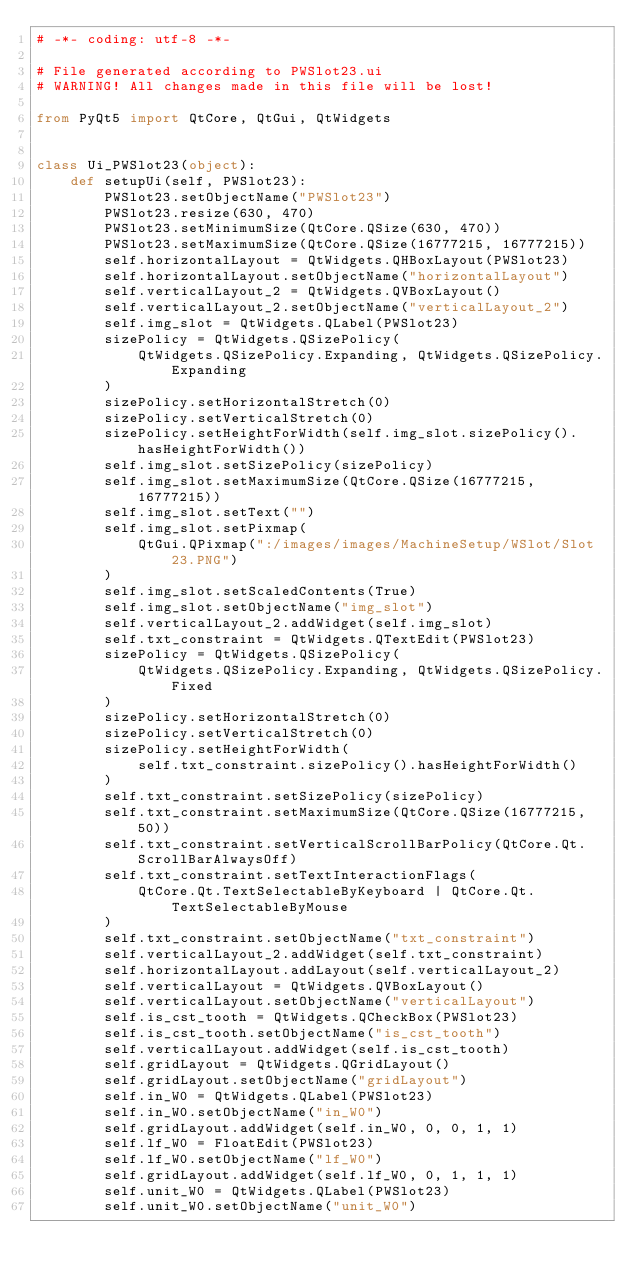<code> <loc_0><loc_0><loc_500><loc_500><_Python_># -*- coding: utf-8 -*-

# File generated according to PWSlot23.ui
# WARNING! All changes made in this file will be lost!

from PyQt5 import QtCore, QtGui, QtWidgets


class Ui_PWSlot23(object):
    def setupUi(self, PWSlot23):
        PWSlot23.setObjectName("PWSlot23")
        PWSlot23.resize(630, 470)
        PWSlot23.setMinimumSize(QtCore.QSize(630, 470))
        PWSlot23.setMaximumSize(QtCore.QSize(16777215, 16777215))
        self.horizontalLayout = QtWidgets.QHBoxLayout(PWSlot23)
        self.horizontalLayout.setObjectName("horizontalLayout")
        self.verticalLayout_2 = QtWidgets.QVBoxLayout()
        self.verticalLayout_2.setObjectName("verticalLayout_2")
        self.img_slot = QtWidgets.QLabel(PWSlot23)
        sizePolicy = QtWidgets.QSizePolicy(
            QtWidgets.QSizePolicy.Expanding, QtWidgets.QSizePolicy.Expanding
        )
        sizePolicy.setHorizontalStretch(0)
        sizePolicy.setVerticalStretch(0)
        sizePolicy.setHeightForWidth(self.img_slot.sizePolicy().hasHeightForWidth())
        self.img_slot.setSizePolicy(sizePolicy)
        self.img_slot.setMaximumSize(QtCore.QSize(16777215, 16777215))
        self.img_slot.setText("")
        self.img_slot.setPixmap(
            QtGui.QPixmap(":/images/images/MachineSetup/WSlot/Slot 23.PNG")
        )
        self.img_slot.setScaledContents(True)
        self.img_slot.setObjectName("img_slot")
        self.verticalLayout_2.addWidget(self.img_slot)
        self.txt_constraint = QtWidgets.QTextEdit(PWSlot23)
        sizePolicy = QtWidgets.QSizePolicy(
            QtWidgets.QSizePolicy.Expanding, QtWidgets.QSizePolicy.Fixed
        )
        sizePolicy.setHorizontalStretch(0)
        sizePolicy.setVerticalStretch(0)
        sizePolicy.setHeightForWidth(
            self.txt_constraint.sizePolicy().hasHeightForWidth()
        )
        self.txt_constraint.setSizePolicy(sizePolicy)
        self.txt_constraint.setMaximumSize(QtCore.QSize(16777215, 50))
        self.txt_constraint.setVerticalScrollBarPolicy(QtCore.Qt.ScrollBarAlwaysOff)
        self.txt_constraint.setTextInteractionFlags(
            QtCore.Qt.TextSelectableByKeyboard | QtCore.Qt.TextSelectableByMouse
        )
        self.txt_constraint.setObjectName("txt_constraint")
        self.verticalLayout_2.addWidget(self.txt_constraint)
        self.horizontalLayout.addLayout(self.verticalLayout_2)
        self.verticalLayout = QtWidgets.QVBoxLayout()
        self.verticalLayout.setObjectName("verticalLayout")
        self.is_cst_tooth = QtWidgets.QCheckBox(PWSlot23)
        self.is_cst_tooth.setObjectName("is_cst_tooth")
        self.verticalLayout.addWidget(self.is_cst_tooth)
        self.gridLayout = QtWidgets.QGridLayout()
        self.gridLayout.setObjectName("gridLayout")
        self.in_W0 = QtWidgets.QLabel(PWSlot23)
        self.in_W0.setObjectName("in_W0")
        self.gridLayout.addWidget(self.in_W0, 0, 0, 1, 1)
        self.lf_W0 = FloatEdit(PWSlot23)
        self.lf_W0.setObjectName("lf_W0")
        self.gridLayout.addWidget(self.lf_W0, 0, 1, 1, 1)
        self.unit_W0 = QtWidgets.QLabel(PWSlot23)
        self.unit_W0.setObjectName("unit_W0")</code> 